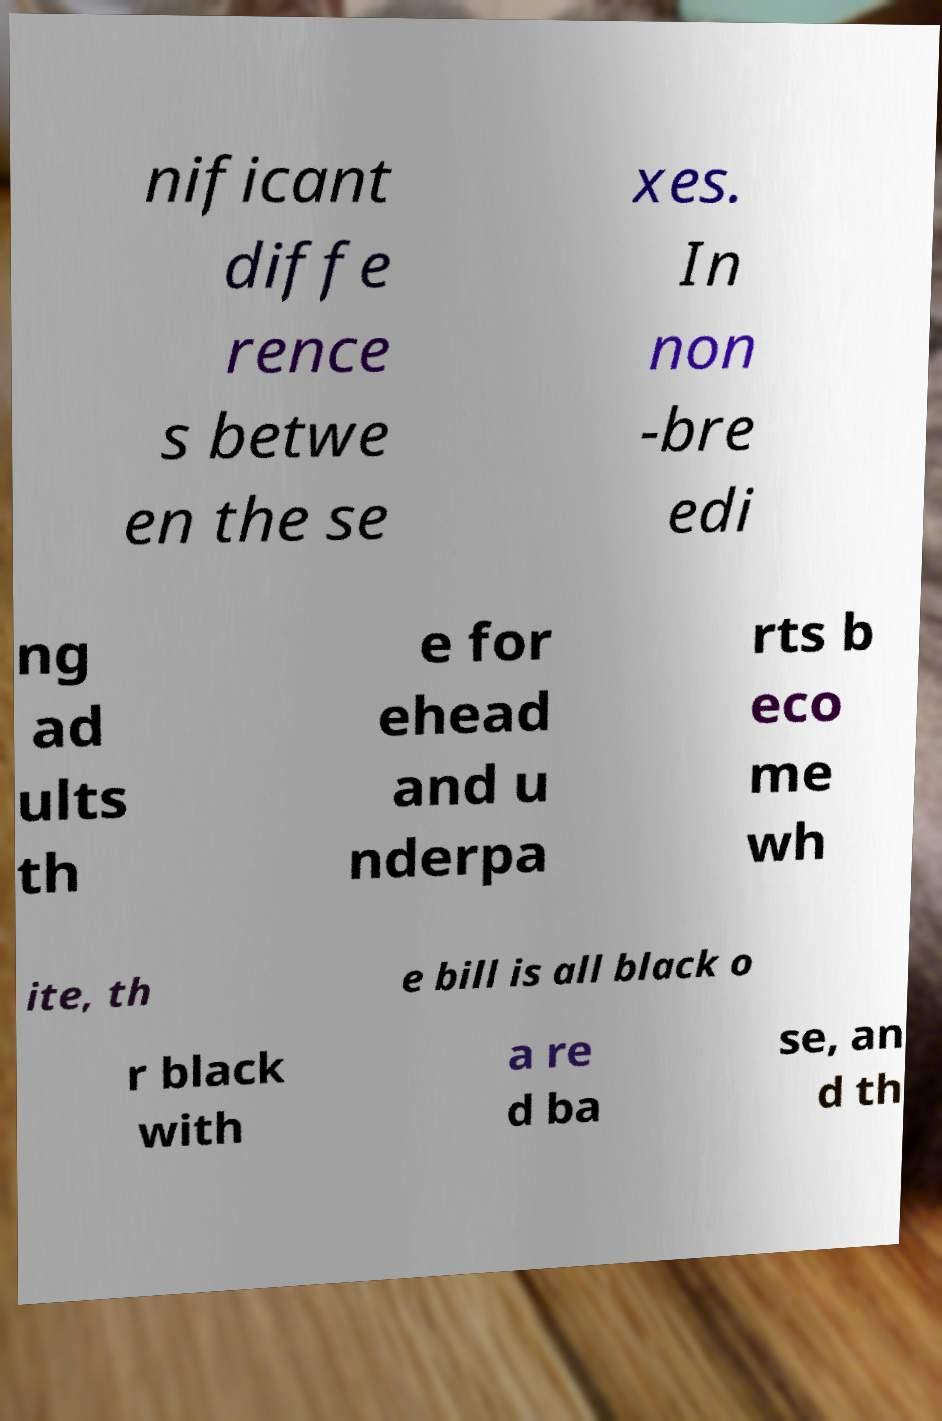For documentation purposes, I need the text within this image transcribed. Could you provide that? nificant diffe rence s betwe en the se xes. In non -bre edi ng ad ults th e for ehead and u nderpa rts b eco me wh ite, th e bill is all black o r black with a re d ba se, an d th 